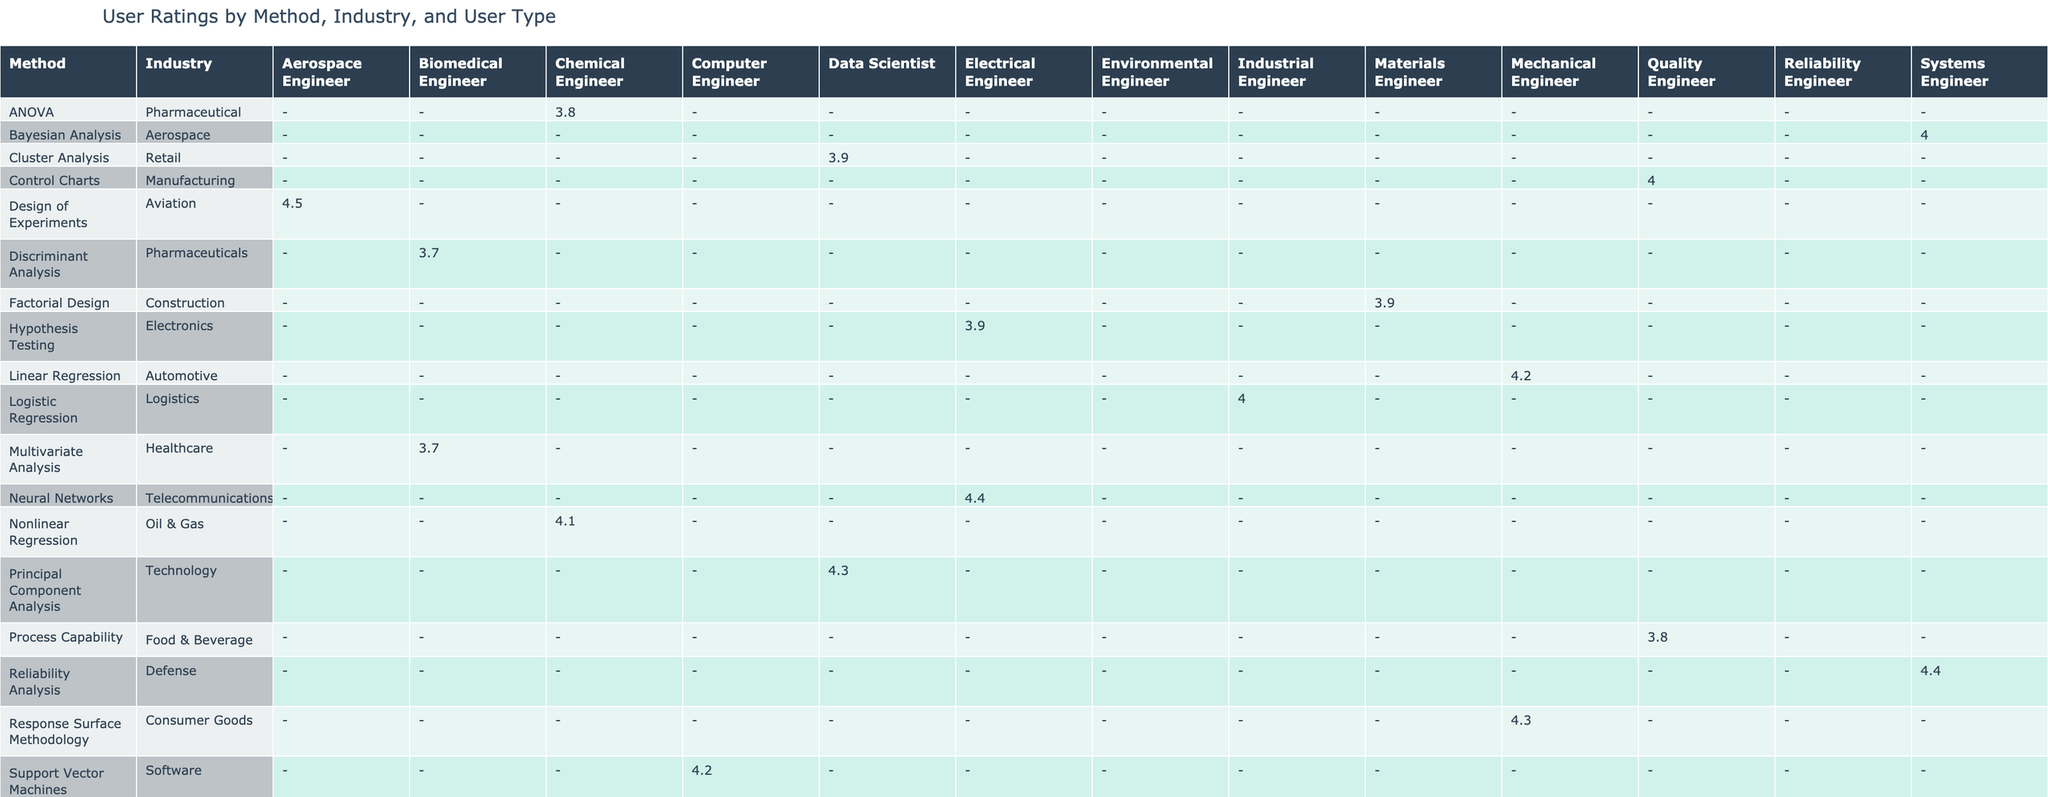What is the User Rating for Linear Regression by Mechanical Engineers in the Automotive industry? The table clearly shows that the User Rating for Linear Regression, categorized under Mechanical Engineers and the Automotive industry, is 4.2. This is directly retrievable from the corresponding cell in the table.
Answer: 4.2 How often do Electrical Engineers use Hypothesis Testing? The table indicates that Electrical Engineers use Hypothesis Testing weekly. This is shown in the 'Usage Frequency' column under Hypothesis Testing.
Answer: Weekly Is the average User Rating for Design of Experiments higher than that for Multivariate Analysis? The User Rating for Design of Experiments is 4.5, while for Multivariate Analysis, it is 3.7. Since 4.5 is greater than 3.7, we conclude that the average User Rating for Design of Experiments is indeed higher.
Answer: Yes What is the total average User Rating for all methods used by Quality Engineers? There are two methods used by Quality Engineers: Control Charts (User Rating 4.0) and Process Capability (User Rating 3.8). To find the total average, we add the two ratings: (4.0 + 3.8) / 2 = 3.9. Thus, the total average User Rating for Quality Engineers is 3.9.
Answer: 3.9 For which statistical method do Systems Engineers have the highest User Rating? Systems Engineers use two methods: Reliability Analysis with a User Rating of 4.4 and Bayesian Analysis with a User Rating of 4.0. The maximum value is 4.4, which corresponds to Reliability Analysis, making it the method with the highest User Rating for Systems Engineers.
Answer: Reliability Analysis Which industry has the lowest average User Rating across all methods? By checking the User Ratings for each industry, we find: Automotive (4.2, 4.2), Pharmaceutical (3.8, 3.7), Aviation (4.5), Manufacturing (4.0), Electronics (3.9), Technology (4.3), Energy (4.1), Healthcare (3.7), Logistics (4.0), Construction (3.9). The lowest average can be calculated by summing the respective ratings and then dividing by the number of methods per industry. The Pharmaceutical industry has the lowest average User Rating of 3.75.
Answer: Pharmaceutical Do Data Scientists have a higher User Rating on Cluster Analysis or Principal Component Analysis? The User Rating for Cluster Analysis is 3.9 while for Principal Component Analysis, it is 4.3. Since 4.3 is greater than 3.9, Data Scientists have a higher User Rating on Principal Component Analysis compared to Cluster Analysis.
Answer: Principal Component Analysis Which User Type uses Nonlinear Regression the most frequently? The table tells us that Nonlinear Regression is used by Chemical Engineers, and their usage frequency is weekly. This can be found in the row corresponding to Nonlinear Regression.
Answer: Weekly What is the average time spent by Mechanical Engineers on Response Surface Methodology? The table shows that the average time spent by Mechanical Engineers on Response Surface Methodology is 55 minutes, as denoted in the respective cell under this method.
Answer: 55 minutes 